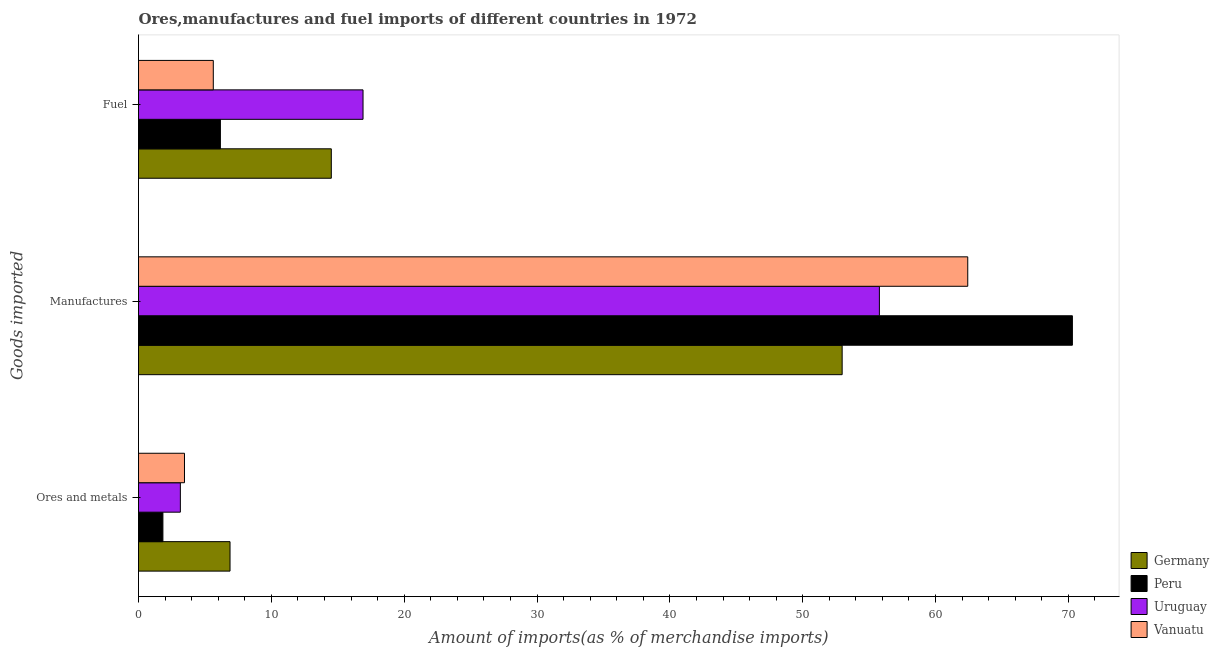How many groups of bars are there?
Make the answer very short. 3. Are the number of bars on each tick of the Y-axis equal?
Give a very brief answer. Yes. How many bars are there on the 3rd tick from the top?
Your answer should be compact. 4. What is the label of the 2nd group of bars from the top?
Give a very brief answer. Manufactures. What is the percentage of fuel imports in Germany?
Your answer should be compact. 14.51. Across all countries, what is the maximum percentage of ores and metals imports?
Offer a terse response. 6.89. Across all countries, what is the minimum percentage of ores and metals imports?
Your answer should be compact. 1.84. In which country was the percentage of manufactures imports maximum?
Provide a short and direct response. Peru. In which country was the percentage of fuel imports minimum?
Provide a succinct answer. Vanuatu. What is the total percentage of manufactures imports in the graph?
Provide a short and direct response. 241.47. What is the difference between the percentage of ores and metals imports in Vanuatu and that in Peru?
Make the answer very short. 1.62. What is the difference between the percentage of ores and metals imports in Vanuatu and the percentage of manufactures imports in Peru?
Keep it short and to the point. -66.84. What is the average percentage of manufactures imports per country?
Your response must be concise. 60.37. What is the difference between the percentage of manufactures imports and percentage of ores and metals imports in Uruguay?
Your answer should be compact. 52.62. What is the ratio of the percentage of manufactures imports in Germany to that in Peru?
Offer a terse response. 0.75. What is the difference between the highest and the second highest percentage of ores and metals imports?
Your response must be concise. 3.43. What is the difference between the highest and the lowest percentage of manufactures imports?
Your response must be concise. 17.33. Is the sum of the percentage of fuel imports in Germany and Vanuatu greater than the maximum percentage of manufactures imports across all countries?
Provide a short and direct response. No. Is it the case that in every country, the sum of the percentage of ores and metals imports and percentage of manufactures imports is greater than the percentage of fuel imports?
Your answer should be very brief. Yes. Are all the bars in the graph horizontal?
Your answer should be very brief. Yes. How many countries are there in the graph?
Provide a short and direct response. 4. What is the difference between two consecutive major ticks on the X-axis?
Ensure brevity in your answer.  10. Are the values on the major ticks of X-axis written in scientific E-notation?
Your response must be concise. No. Does the graph contain any zero values?
Offer a terse response. No. Does the graph contain grids?
Offer a very short reply. No. How are the legend labels stacked?
Your answer should be compact. Vertical. What is the title of the graph?
Your answer should be very brief. Ores,manufactures and fuel imports of different countries in 1972. Does "Sub-Saharan Africa (developing only)" appear as one of the legend labels in the graph?
Make the answer very short. No. What is the label or title of the X-axis?
Make the answer very short. Amount of imports(as % of merchandise imports). What is the label or title of the Y-axis?
Provide a short and direct response. Goods imported. What is the Amount of imports(as % of merchandise imports) in Germany in Ores and metals?
Your answer should be very brief. 6.89. What is the Amount of imports(as % of merchandise imports) of Peru in Ores and metals?
Give a very brief answer. 1.84. What is the Amount of imports(as % of merchandise imports) in Uruguay in Ores and metals?
Ensure brevity in your answer.  3.15. What is the Amount of imports(as % of merchandise imports) in Vanuatu in Ores and metals?
Provide a succinct answer. 3.46. What is the Amount of imports(as % of merchandise imports) in Germany in Manufactures?
Make the answer very short. 52.97. What is the Amount of imports(as % of merchandise imports) of Peru in Manufactures?
Provide a succinct answer. 70.3. What is the Amount of imports(as % of merchandise imports) in Uruguay in Manufactures?
Keep it short and to the point. 55.77. What is the Amount of imports(as % of merchandise imports) in Vanuatu in Manufactures?
Provide a succinct answer. 62.42. What is the Amount of imports(as % of merchandise imports) in Germany in Fuel?
Give a very brief answer. 14.51. What is the Amount of imports(as % of merchandise imports) in Peru in Fuel?
Provide a succinct answer. 6.16. What is the Amount of imports(as % of merchandise imports) of Uruguay in Fuel?
Your answer should be very brief. 16.9. What is the Amount of imports(as % of merchandise imports) of Vanuatu in Fuel?
Provide a succinct answer. 5.63. Across all Goods imported, what is the maximum Amount of imports(as % of merchandise imports) of Germany?
Offer a very short reply. 52.97. Across all Goods imported, what is the maximum Amount of imports(as % of merchandise imports) of Peru?
Your answer should be very brief. 70.3. Across all Goods imported, what is the maximum Amount of imports(as % of merchandise imports) of Uruguay?
Your answer should be compact. 55.77. Across all Goods imported, what is the maximum Amount of imports(as % of merchandise imports) of Vanuatu?
Provide a short and direct response. 62.42. Across all Goods imported, what is the minimum Amount of imports(as % of merchandise imports) of Germany?
Make the answer very short. 6.89. Across all Goods imported, what is the minimum Amount of imports(as % of merchandise imports) in Peru?
Your answer should be compact. 1.84. Across all Goods imported, what is the minimum Amount of imports(as % of merchandise imports) in Uruguay?
Provide a succinct answer. 3.15. Across all Goods imported, what is the minimum Amount of imports(as % of merchandise imports) in Vanuatu?
Offer a very short reply. 3.46. What is the total Amount of imports(as % of merchandise imports) in Germany in the graph?
Make the answer very short. 74.37. What is the total Amount of imports(as % of merchandise imports) in Peru in the graph?
Your answer should be very brief. 78.3. What is the total Amount of imports(as % of merchandise imports) in Uruguay in the graph?
Your answer should be very brief. 75.82. What is the total Amount of imports(as % of merchandise imports) of Vanuatu in the graph?
Your answer should be very brief. 71.51. What is the difference between the Amount of imports(as % of merchandise imports) of Germany in Ores and metals and that in Manufactures?
Keep it short and to the point. -46.08. What is the difference between the Amount of imports(as % of merchandise imports) in Peru in Ores and metals and that in Manufactures?
Offer a terse response. -68.46. What is the difference between the Amount of imports(as % of merchandise imports) in Uruguay in Ores and metals and that in Manufactures?
Offer a very short reply. -52.62. What is the difference between the Amount of imports(as % of merchandise imports) of Vanuatu in Ores and metals and that in Manufactures?
Your answer should be compact. -58.96. What is the difference between the Amount of imports(as % of merchandise imports) of Germany in Ores and metals and that in Fuel?
Offer a very short reply. -7.62. What is the difference between the Amount of imports(as % of merchandise imports) of Peru in Ores and metals and that in Fuel?
Your answer should be compact. -4.33. What is the difference between the Amount of imports(as % of merchandise imports) of Uruguay in Ores and metals and that in Fuel?
Ensure brevity in your answer.  -13.75. What is the difference between the Amount of imports(as % of merchandise imports) in Vanuatu in Ores and metals and that in Fuel?
Offer a terse response. -2.17. What is the difference between the Amount of imports(as % of merchandise imports) of Germany in Manufactures and that in Fuel?
Offer a terse response. 38.46. What is the difference between the Amount of imports(as % of merchandise imports) in Peru in Manufactures and that in Fuel?
Provide a succinct answer. 64.14. What is the difference between the Amount of imports(as % of merchandise imports) of Uruguay in Manufactures and that in Fuel?
Your answer should be compact. 38.87. What is the difference between the Amount of imports(as % of merchandise imports) in Vanuatu in Manufactures and that in Fuel?
Provide a short and direct response. 56.79. What is the difference between the Amount of imports(as % of merchandise imports) in Germany in Ores and metals and the Amount of imports(as % of merchandise imports) in Peru in Manufactures?
Offer a terse response. -63.41. What is the difference between the Amount of imports(as % of merchandise imports) of Germany in Ores and metals and the Amount of imports(as % of merchandise imports) of Uruguay in Manufactures?
Make the answer very short. -48.88. What is the difference between the Amount of imports(as % of merchandise imports) of Germany in Ores and metals and the Amount of imports(as % of merchandise imports) of Vanuatu in Manufactures?
Provide a succinct answer. -55.53. What is the difference between the Amount of imports(as % of merchandise imports) in Peru in Ores and metals and the Amount of imports(as % of merchandise imports) in Uruguay in Manufactures?
Ensure brevity in your answer.  -53.94. What is the difference between the Amount of imports(as % of merchandise imports) of Peru in Ores and metals and the Amount of imports(as % of merchandise imports) of Vanuatu in Manufactures?
Ensure brevity in your answer.  -60.59. What is the difference between the Amount of imports(as % of merchandise imports) in Uruguay in Ores and metals and the Amount of imports(as % of merchandise imports) in Vanuatu in Manufactures?
Offer a terse response. -59.27. What is the difference between the Amount of imports(as % of merchandise imports) of Germany in Ores and metals and the Amount of imports(as % of merchandise imports) of Peru in Fuel?
Provide a succinct answer. 0.73. What is the difference between the Amount of imports(as % of merchandise imports) in Germany in Ores and metals and the Amount of imports(as % of merchandise imports) in Uruguay in Fuel?
Keep it short and to the point. -10.01. What is the difference between the Amount of imports(as % of merchandise imports) of Germany in Ores and metals and the Amount of imports(as % of merchandise imports) of Vanuatu in Fuel?
Provide a short and direct response. 1.26. What is the difference between the Amount of imports(as % of merchandise imports) of Peru in Ores and metals and the Amount of imports(as % of merchandise imports) of Uruguay in Fuel?
Provide a succinct answer. -15.07. What is the difference between the Amount of imports(as % of merchandise imports) of Peru in Ores and metals and the Amount of imports(as % of merchandise imports) of Vanuatu in Fuel?
Your response must be concise. -3.79. What is the difference between the Amount of imports(as % of merchandise imports) of Uruguay in Ores and metals and the Amount of imports(as % of merchandise imports) of Vanuatu in Fuel?
Make the answer very short. -2.48. What is the difference between the Amount of imports(as % of merchandise imports) of Germany in Manufactures and the Amount of imports(as % of merchandise imports) of Peru in Fuel?
Give a very brief answer. 46.8. What is the difference between the Amount of imports(as % of merchandise imports) of Germany in Manufactures and the Amount of imports(as % of merchandise imports) of Uruguay in Fuel?
Ensure brevity in your answer.  36.07. What is the difference between the Amount of imports(as % of merchandise imports) in Germany in Manufactures and the Amount of imports(as % of merchandise imports) in Vanuatu in Fuel?
Provide a succinct answer. 47.34. What is the difference between the Amount of imports(as % of merchandise imports) in Peru in Manufactures and the Amount of imports(as % of merchandise imports) in Uruguay in Fuel?
Your answer should be compact. 53.4. What is the difference between the Amount of imports(as % of merchandise imports) of Peru in Manufactures and the Amount of imports(as % of merchandise imports) of Vanuatu in Fuel?
Your answer should be compact. 64.67. What is the difference between the Amount of imports(as % of merchandise imports) of Uruguay in Manufactures and the Amount of imports(as % of merchandise imports) of Vanuatu in Fuel?
Give a very brief answer. 50.14. What is the average Amount of imports(as % of merchandise imports) in Germany per Goods imported?
Offer a terse response. 24.79. What is the average Amount of imports(as % of merchandise imports) in Peru per Goods imported?
Offer a terse response. 26.1. What is the average Amount of imports(as % of merchandise imports) of Uruguay per Goods imported?
Keep it short and to the point. 25.27. What is the average Amount of imports(as % of merchandise imports) in Vanuatu per Goods imported?
Your response must be concise. 23.84. What is the difference between the Amount of imports(as % of merchandise imports) in Germany and Amount of imports(as % of merchandise imports) in Peru in Ores and metals?
Give a very brief answer. 5.05. What is the difference between the Amount of imports(as % of merchandise imports) of Germany and Amount of imports(as % of merchandise imports) of Uruguay in Ores and metals?
Ensure brevity in your answer.  3.74. What is the difference between the Amount of imports(as % of merchandise imports) of Germany and Amount of imports(as % of merchandise imports) of Vanuatu in Ores and metals?
Provide a short and direct response. 3.43. What is the difference between the Amount of imports(as % of merchandise imports) in Peru and Amount of imports(as % of merchandise imports) in Uruguay in Ores and metals?
Make the answer very short. -1.31. What is the difference between the Amount of imports(as % of merchandise imports) in Peru and Amount of imports(as % of merchandise imports) in Vanuatu in Ores and metals?
Offer a terse response. -1.62. What is the difference between the Amount of imports(as % of merchandise imports) of Uruguay and Amount of imports(as % of merchandise imports) of Vanuatu in Ores and metals?
Keep it short and to the point. -0.31. What is the difference between the Amount of imports(as % of merchandise imports) in Germany and Amount of imports(as % of merchandise imports) in Peru in Manufactures?
Give a very brief answer. -17.33. What is the difference between the Amount of imports(as % of merchandise imports) in Germany and Amount of imports(as % of merchandise imports) in Uruguay in Manufactures?
Offer a terse response. -2.8. What is the difference between the Amount of imports(as % of merchandise imports) in Germany and Amount of imports(as % of merchandise imports) in Vanuatu in Manufactures?
Your answer should be very brief. -9.45. What is the difference between the Amount of imports(as % of merchandise imports) in Peru and Amount of imports(as % of merchandise imports) in Uruguay in Manufactures?
Provide a succinct answer. 14.53. What is the difference between the Amount of imports(as % of merchandise imports) of Peru and Amount of imports(as % of merchandise imports) of Vanuatu in Manufactures?
Provide a short and direct response. 7.88. What is the difference between the Amount of imports(as % of merchandise imports) of Uruguay and Amount of imports(as % of merchandise imports) of Vanuatu in Manufactures?
Offer a very short reply. -6.65. What is the difference between the Amount of imports(as % of merchandise imports) in Germany and Amount of imports(as % of merchandise imports) in Peru in Fuel?
Your response must be concise. 8.35. What is the difference between the Amount of imports(as % of merchandise imports) in Germany and Amount of imports(as % of merchandise imports) in Uruguay in Fuel?
Make the answer very short. -2.39. What is the difference between the Amount of imports(as % of merchandise imports) of Germany and Amount of imports(as % of merchandise imports) of Vanuatu in Fuel?
Your response must be concise. 8.88. What is the difference between the Amount of imports(as % of merchandise imports) in Peru and Amount of imports(as % of merchandise imports) in Uruguay in Fuel?
Offer a terse response. -10.74. What is the difference between the Amount of imports(as % of merchandise imports) in Peru and Amount of imports(as % of merchandise imports) in Vanuatu in Fuel?
Make the answer very short. 0.53. What is the difference between the Amount of imports(as % of merchandise imports) in Uruguay and Amount of imports(as % of merchandise imports) in Vanuatu in Fuel?
Your answer should be very brief. 11.27. What is the ratio of the Amount of imports(as % of merchandise imports) of Germany in Ores and metals to that in Manufactures?
Make the answer very short. 0.13. What is the ratio of the Amount of imports(as % of merchandise imports) of Peru in Ores and metals to that in Manufactures?
Your answer should be compact. 0.03. What is the ratio of the Amount of imports(as % of merchandise imports) of Uruguay in Ores and metals to that in Manufactures?
Provide a short and direct response. 0.06. What is the ratio of the Amount of imports(as % of merchandise imports) of Vanuatu in Ores and metals to that in Manufactures?
Offer a very short reply. 0.06. What is the ratio of the Amount of imports(as % of merchandise imports) of Germany in Ores and metals to that in Fuel?
Offer a terse response. 0.47. What is the ratio of the Amount of imports(as % of merchandise imports) of Peru in Ores and metals to that in Fuel?
Provide a succinct answer. 0.3. What is the ratio of the Amount of imports(as % of merchandise imports) in Uruguay in Ores and metals to that in Fuel?
Offer a very short reply. 0.19. What is the ratio of the Amount of imports(as % of merchandise imports) in Vanuatu in Ores and metals to that in Fuel?
Give a very brief answer. 0.61. What is the ratio of the Amount of imports(as % of merchandise imports) in Germany in Manufactures to that in Fuel?
Offer a terse response. 3.65. What is the ratio of the Amount of imports(as % of merchandise imports) in Peru in Manufactures to that in Fuel?
Provide a succinct answer. 11.4. What is the ratio of the Amount of imports(as % of merchandise imports) in Uruguay in Manufactures to that in Fuel?
Give a very brief answer. 3.3. What is the ratio of the Amount of imports(as % of merchandise imports) in Vanuatu in Manufactures to that in Fuel?
Make the answer very short. 11.09. What is the difference between the highest and the second highest Amount of imports(as % of merchandise imports) of Germany?
Provide a succinct answer. 38.46. What is the difference between the highest and the second highest Amount of imports(as % of merchandise imports) of Peru?
Your answer should be compact. 64.14. What is the difference between the highest and the second highest Amount of imports(as % of merchandise imports) of Uruguay?
Give a very brief answer. 38.87. What is the difference between the highest and the second highest Amount of imports(as % of merchandise imports) of Vanuatu?
Your response must be concise. 56.79. What is the difference between the highest and the lowest Amount of imports(as % of merchandise imports) of Germany?
Offer a terse response. 46.08. What is the difference between the highest and the lowest Amount of imports(as % of merchandise imports) of Peru?
Offer a terse response. 68.46. What is the difference between the highest and the lowest Amount of imports(as % of merchandise imports) of Uruguay?
Offer a terse response. 52.62. What is the difference between the highest and the lowest Amount of imports(as % of merchandise imports) of Vanuatu?
Offer a terse response. 58.96. 